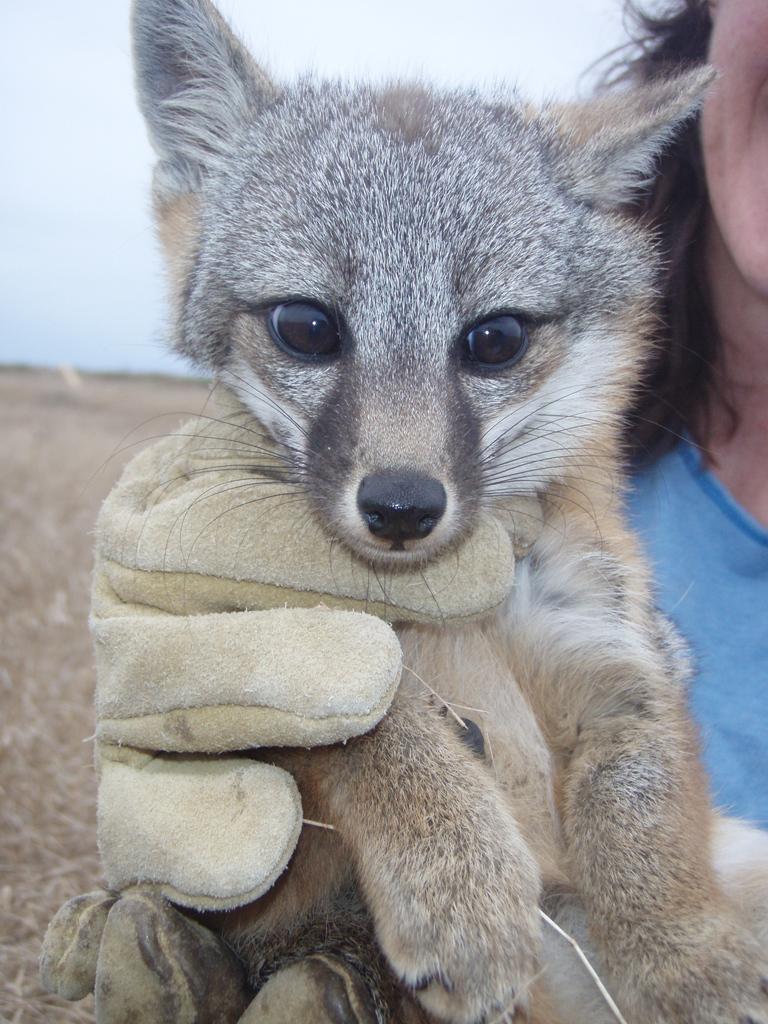Could you give a brief overview of what you see in this image? In this image I can see a person is holding the animal. The animal is in brown, black and white color. Person is wearing blue color top and a glove. Background is in white and brown color. 